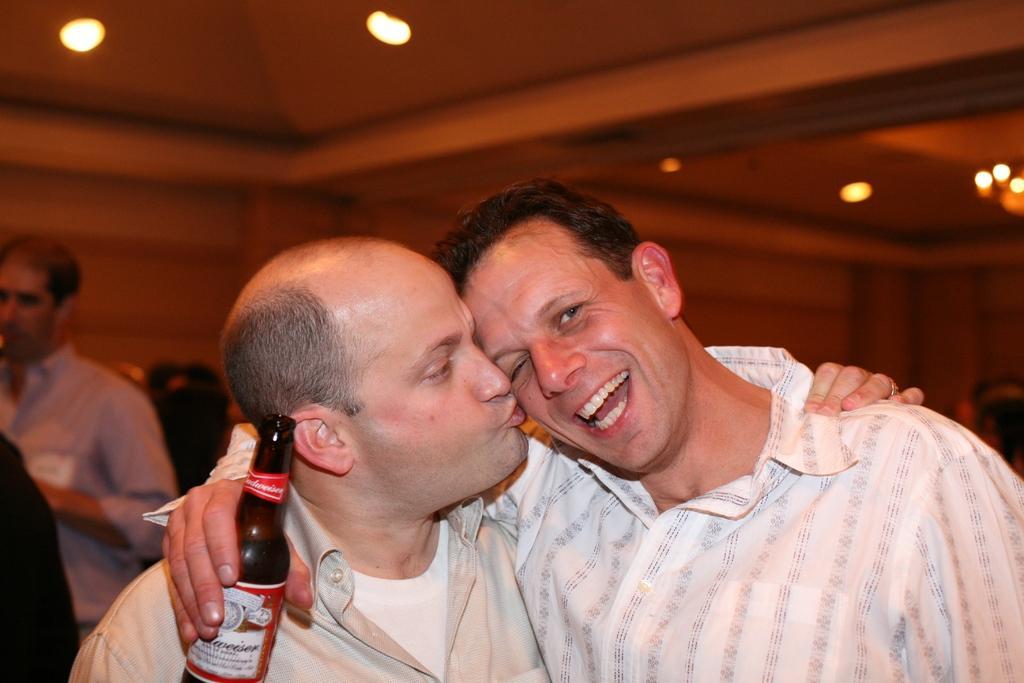In one or two sentences, can you explain what this image depicts? In this image we can see two persons. On the right side there is a person smiling and holding a bottle. At the background we can see a light. 